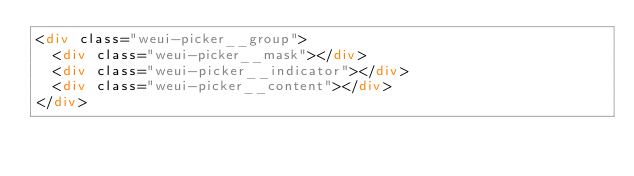Convert code to text. <code><loc_0><loc_0><loc_500><loc_500><_HTML_><div class="weui-picker__group">
  <div class="weui-picker__mask"></div>
  <div class="weui-picker__indicator"></div>
  <div class="weui-picker__content"></div>
</div>
</code> 